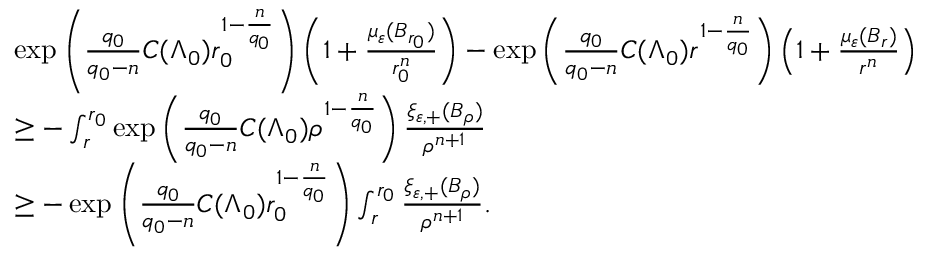<formula> <loc_0><loc_0><loc_500><loc_500>\begin{array} { r l } & { \exp \left ( \frac { q _ { 0 } } { q _ { 0 } - n } C ( \Lambda _ { 0 } ) r _ { 0 } ^ { 1 - \frac { n } { q _ { 0 } } } \right ) \left ( 1 + \frac { \mu _ { \varepsilon } ( B _ { r _ { 0 } } ) } { r _ { 0 } ^ { n } } \right ) - \exp \left ( \frac { q _ { 0 } } { q _ { 0 } - n } C ( \Lambda _ { 0 } ) r ^ { 1 - \frac { n } { q _ { 0 } } } \right ) \left ( 1 + \frac { \mu _ { \varepsilon } ( B _ { r } ) } { r ^ { n } } \right ) } \\ & { \geq - \int _ { r } ^ { r _ { 0 } } \exp \left ( \frac { q _ { 0 } } { q _ { 0 } - n } C ( \Lambda _ { 0 } ) \rho ^ { 1 - \frac { n } { q _ { 0 } } } \right ) \frac { \xi _ { \varepsilon , + } ( B _ { \rho } ) } { \rho ^ { n + 1 } } } \\ & { \geq - \exp \left ( \frac { q _ { 0 } } { q _ { 0 } - n } C ( \Lambda _ { 0 } ) r _ { 0 } ^ { 1 - \frac { n } { q _ { 0 } } } \right ) \int _ { r } ^ { r _ { 0 } } \frac { \xi _ { \varepsilon , + } ( B _ { \rho } ) } { \rho ^ { n + 1 } } . } \end{array}</formula> 